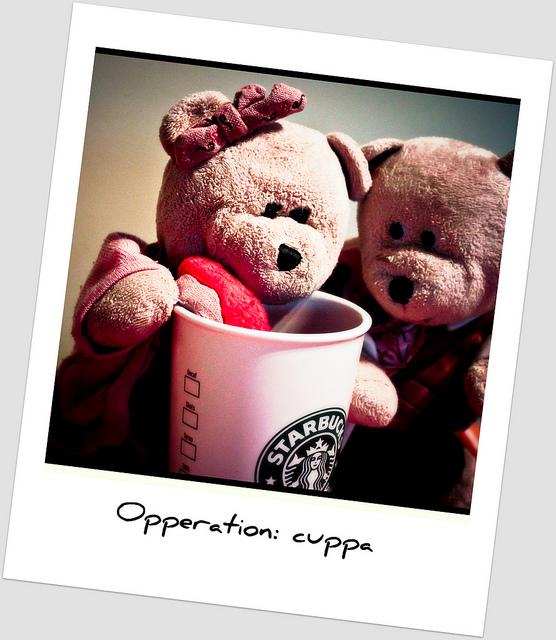Can this animals drink the coffee?
Give a very brief answer. No. What brand name is on the cup?
Short answer required. Starbucks. Is the cup full?
Quick response, please. No. 